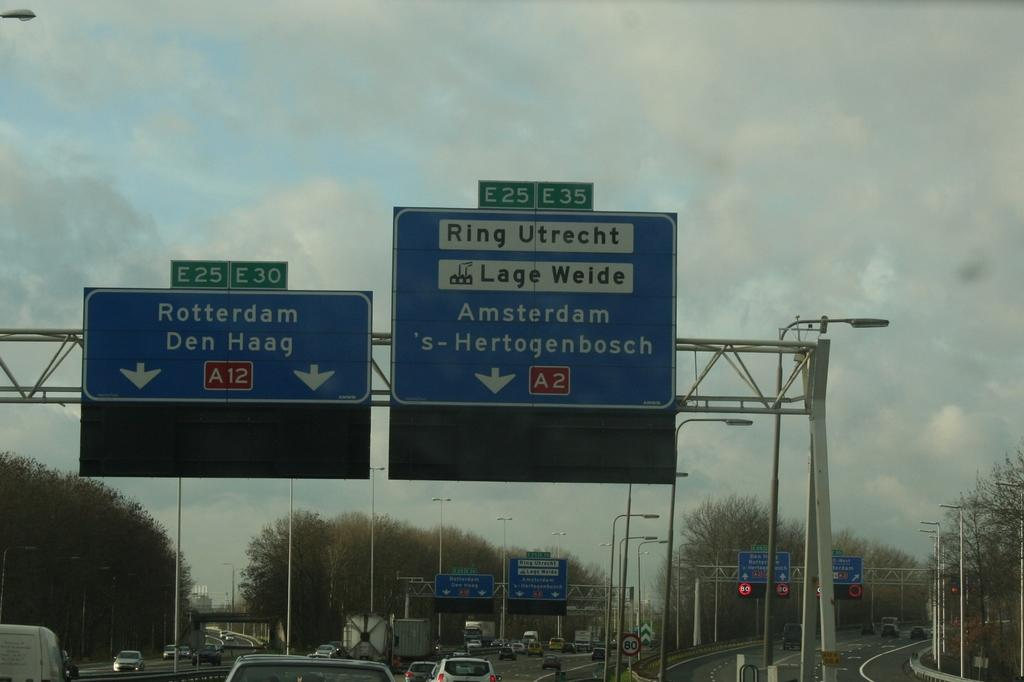<image>
Render a clear and concise summary of the photo. A traffic sign for Rotterdam next to one for Amsterdam. 